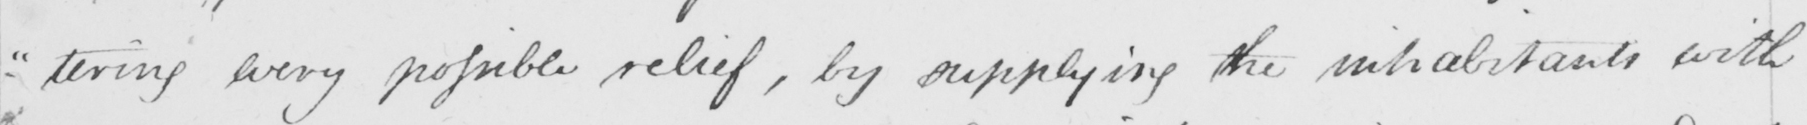What does this handwritten line say? - " tering every possible relief , by supplying the inhabitants with 